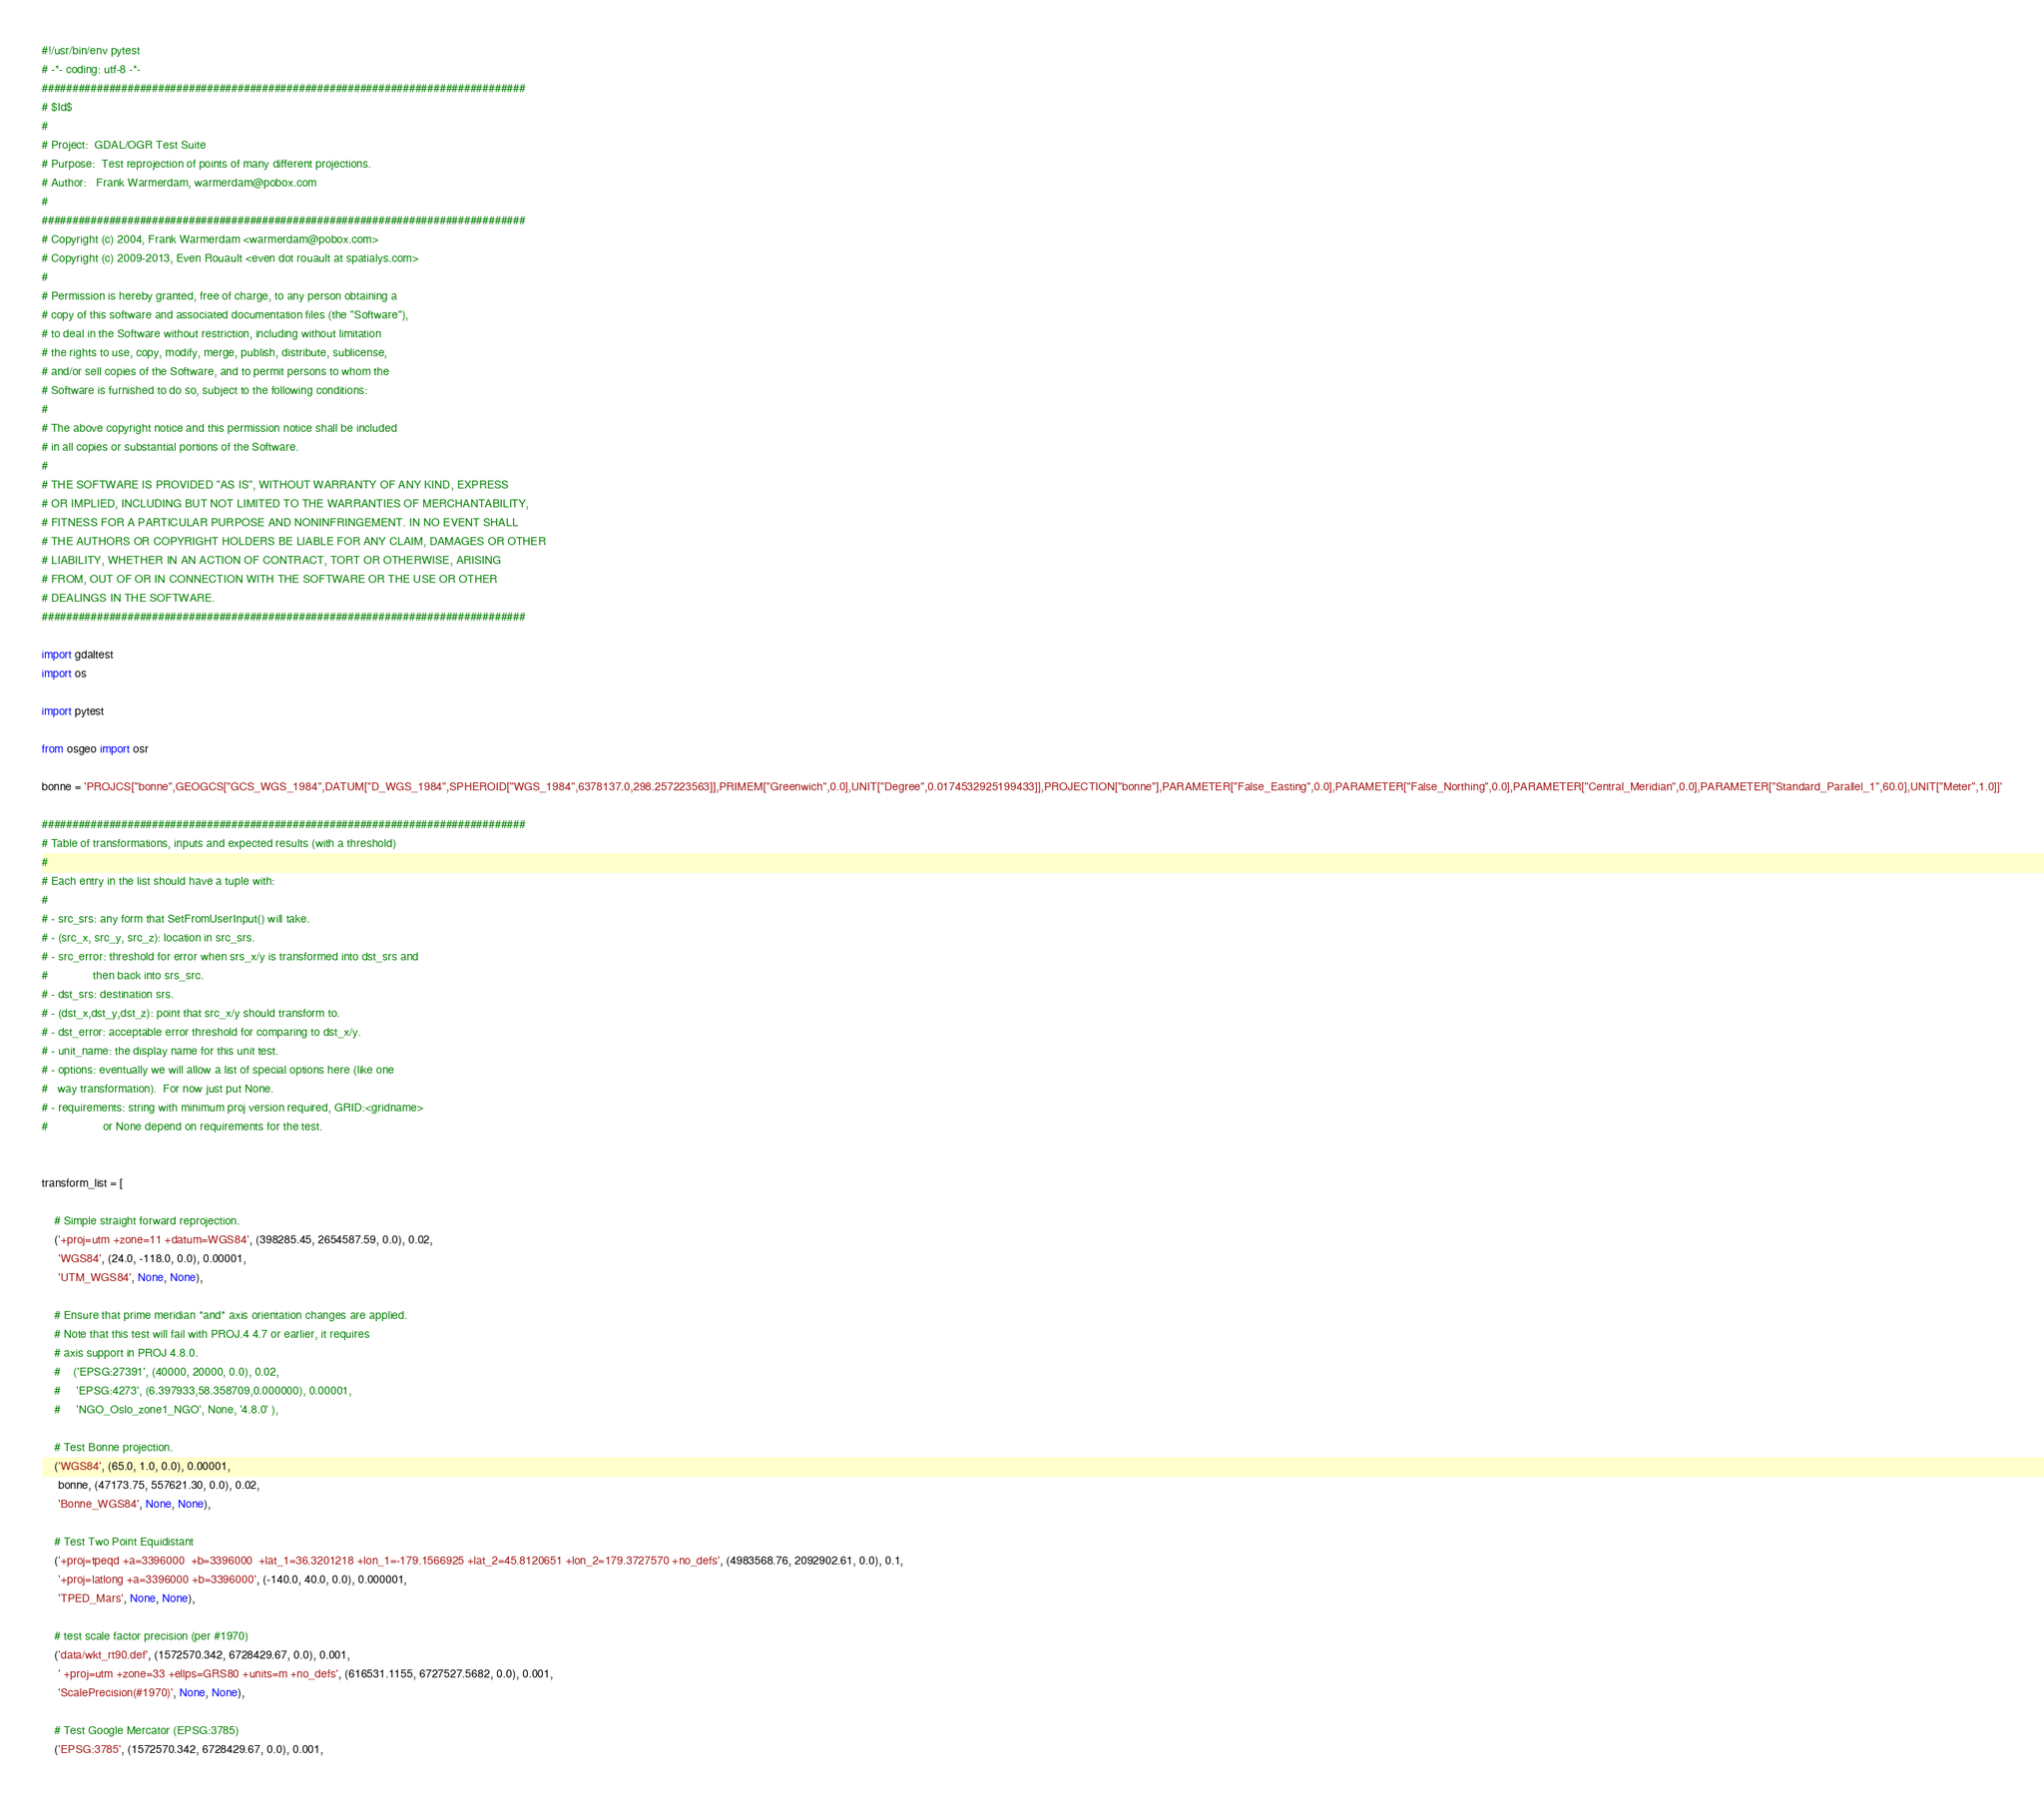<code> <loc_0><loc_0><loc_500><loc_500><_Python_>#!/usr/bin/env pytest
# -*- coding: utf-8 -*-
###############################################################################
# $Id$
#
# Project:  GDAL/OGR Test Suite
# Purpose:  Test reprojection of points of many different projections.
# Author:   Frank Warmerdam, warmerdam@pobox.com
#
###############################################################################
# Copyright (c) 2004, Frank Warmerdam <warmerdam@pobox.com>
# Copyright (c) 2009-2013, Even Rouault <even dot rouault at spatialys.com>
#
# Permission is hereby granted, free of charge, to any person obtaining a
# copy of this software and associated documentation files (the "Software"),
# to deal in the Software without restriction, including without limitation
# the rights to use, copy, modify, merge, publish, distribute, sublicense,
# and/or sell copies of the Software, and to permit persons to whom the
# Software is furnished to do so, subject to the following conditions:
#
# The above copyright notice and this permission notice shall be included
# in all copies or substantial portions of the Software.
#
# THE SOFTWARE IS PROVIDED "AS IS", WITHOUT WARRANTY OF ANY KIND, EXPRESS
# OR IMPLIED, INCLUDING BUT NOT LIMITED TO THE WARRANTIES OF MERCHANTABILITY,
# FITNESS FOR A PARTICULAR PURPOSE AND NONINFRINGEMENT. IN NO EVENT SHALL
# THE AUTHORS OR COPYRIGHT HOLDERS BE LIABLE FOR ANY CLAIM, DAMAGES OR OTHER
# LIABILITY, WHETHER IN AN ACTION OF CONTRACT, TORT OR OTHERWISE, ARISING
# FROM, OUT OF OR IN CONNECTION WITH THE SOFTWARE OR THE USE OR OTHER
# DEALINGS IN THE SOFTWARE.
###############################################################################

import gdaltest
import os

import pytest

from osgeo import osr

bonne = 'PROJCS["bonne",GEOGCS["GCS_WGS_1984",DATUM["D_WGS_1984",SPHEROID["WGS_1984",6378137.0,298.257223563]],PRIMEM["Greenwich",0.0],UNIT["Degree",0.0174532925199433]],PROJECTION["bonne"],PARAMETER["False_Easting",0.0],PARAMETER["False_Northing",0.0],PARAMETER["Central_Meridian",0.0],PARAMETER["Standard_Parallel_1",60.0],UNIT["Meter",1.0]]'

###############################################################################
# Table of transformations, inputs and expected results (with a threshold)
#
# Each entry in the list should have a tuple with:
#
# - src_srs: any form that SetFromUserInput() will take.
# - (src_x, src_y, src_z): location in src_srs.
# - src_error: threshold for error when srs_x/y is transformed into dst_srs and
#              then back into srs_src.
# - dst_srs: destination srs.
# - (dst_x,dst_y,dst_z): point that src_x/y should transform to.
# - dst_error: acceptable error threshold for comparing to dst_x/y.
# - unit_name: the display name for this unit test.
# - options: eventually we will allow a list of special options here (like one
#   way transformation).  For now just put None.
# - requirements: string with minimum proj version required, GRID:<gridname>
#                 or None depend on requirements for the test.


transform_list = [

    # Simple straight forward reprojection.
    ('+proj=utm +zone=11 +datum=WGS84', (398285.45, 2654587.59, 0.0), 0.02,
     'WGS84', (24.0, -118.0, 0.0), 0.00001,
     'UTM_WGS84', None, None),

    # Ensure that prime meridian *and* axis orientation changes are applied.
    # Note that this test will fail with PROJ.4 4.7 or earlier, it requires
    # axis support in PROJ 4.8.0.
    #    ('EPSG:27391', (40000, 20000, 0.0), 0.02,
    #     'EPSG:4273', (6.397933,58.358709,0.000000), 0.00001,
    #     'NGO_Oslo_zone1_NGO', None, '4.8.0' ),

    # Test Bonne projection.
    ('WGS84', (65.0, 1.0, 0.0), 0.00001,
     bonne, (47173.75, 557621.30, 0.0), 0.02,
     'Bonne_WGS84', None, None),

    # Test Two Point Equidistant
    ('+proj=tpeqd +a=3396000  +b=3396000  +lat_1=36.3201218 +lon_1=-179.1566925 +lat_2=45.8120651 +lon_2=179.3727570 +no_defs', (4983568.76, 2092902.61, 0.0), 0.1,
     '+proj=latlong +a=3396000 +b=3396000', (-140.0, 40.0, 0.0), 0.000001,
     'TPED_Mars', None, None),

    # test scale factor precision (per #1970)
    ('data/wkt_rt90.def', (1572570.342, 6728429.67, 0.0), 0.001,
     ' +proj=utm +zone=33 +ellps=GRS80 +units=m +no_defs', (616531.1155, 6727527.5682, 0.0), 0.001,
     'ScalePrecision(#1970)', None, None),

    # Test Google Mercator (EPSG:3785)
    ('EPSG:3785', (1572570.342, 6728429.67, 0.0), 0.001,</code> 